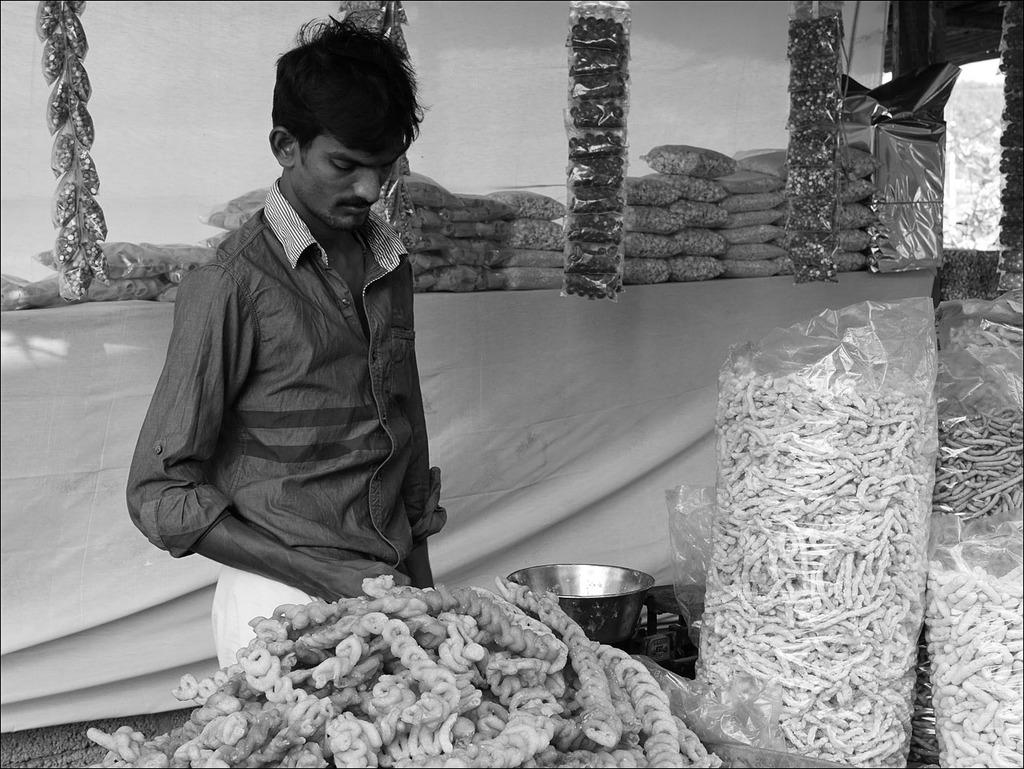What is the main subject of the image? There is a man standing in the image. What else can be seen in the image besides the man? There is food in polythene covers and a vessel in the image. Can you describe the man's clothing in the image? There is a cloth on the back in the image. What type of science experiment is being conducted in the image? There is no science experiment present in the image. How many toes can be seen on the man's feet in the image? The image does not show the man's feet, so the number of toes cannot be determined. 